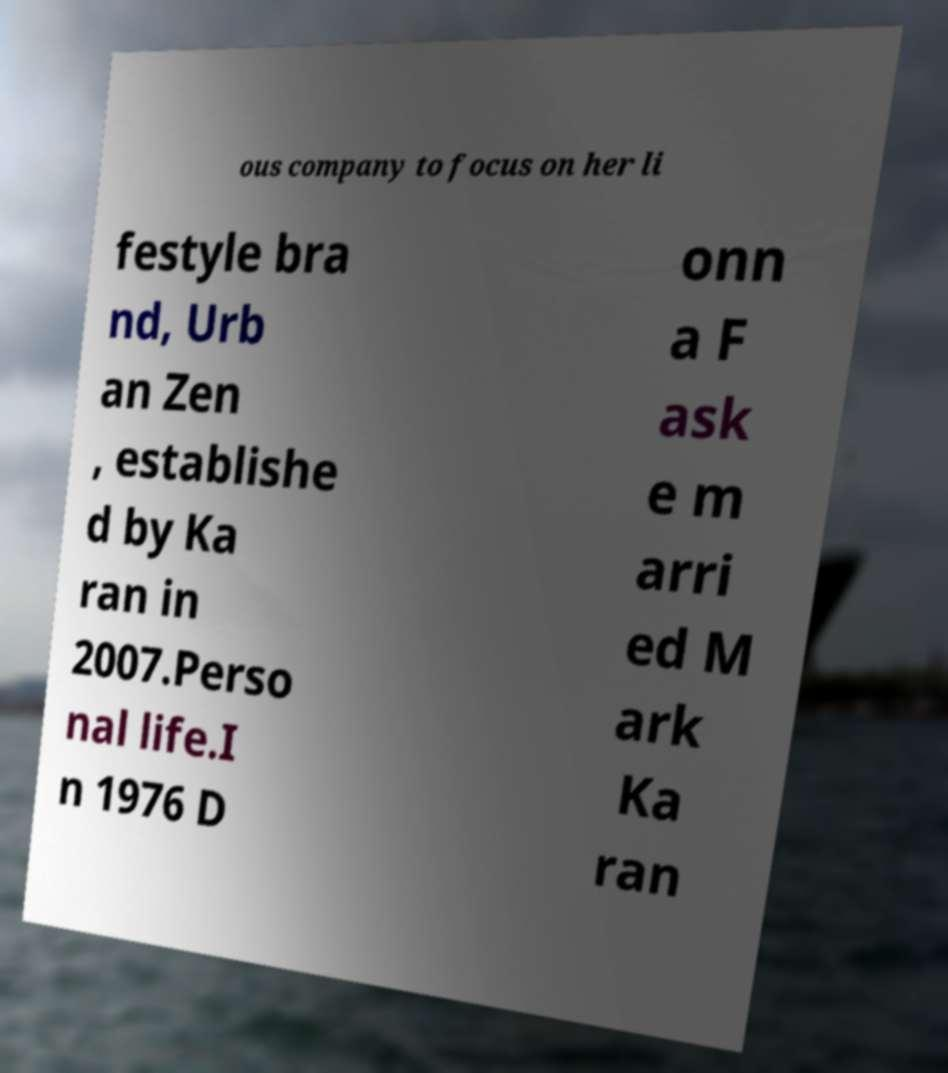What messages or text are displayed in this image? I need them in a readable, typed format. ous company to focus on her li festyle bra nd, Urb an Zen , establishe d by Ka ran in 2007.Perso nal life.I n 1976 D onn a F ask e m arri ed M ark Ka ran 